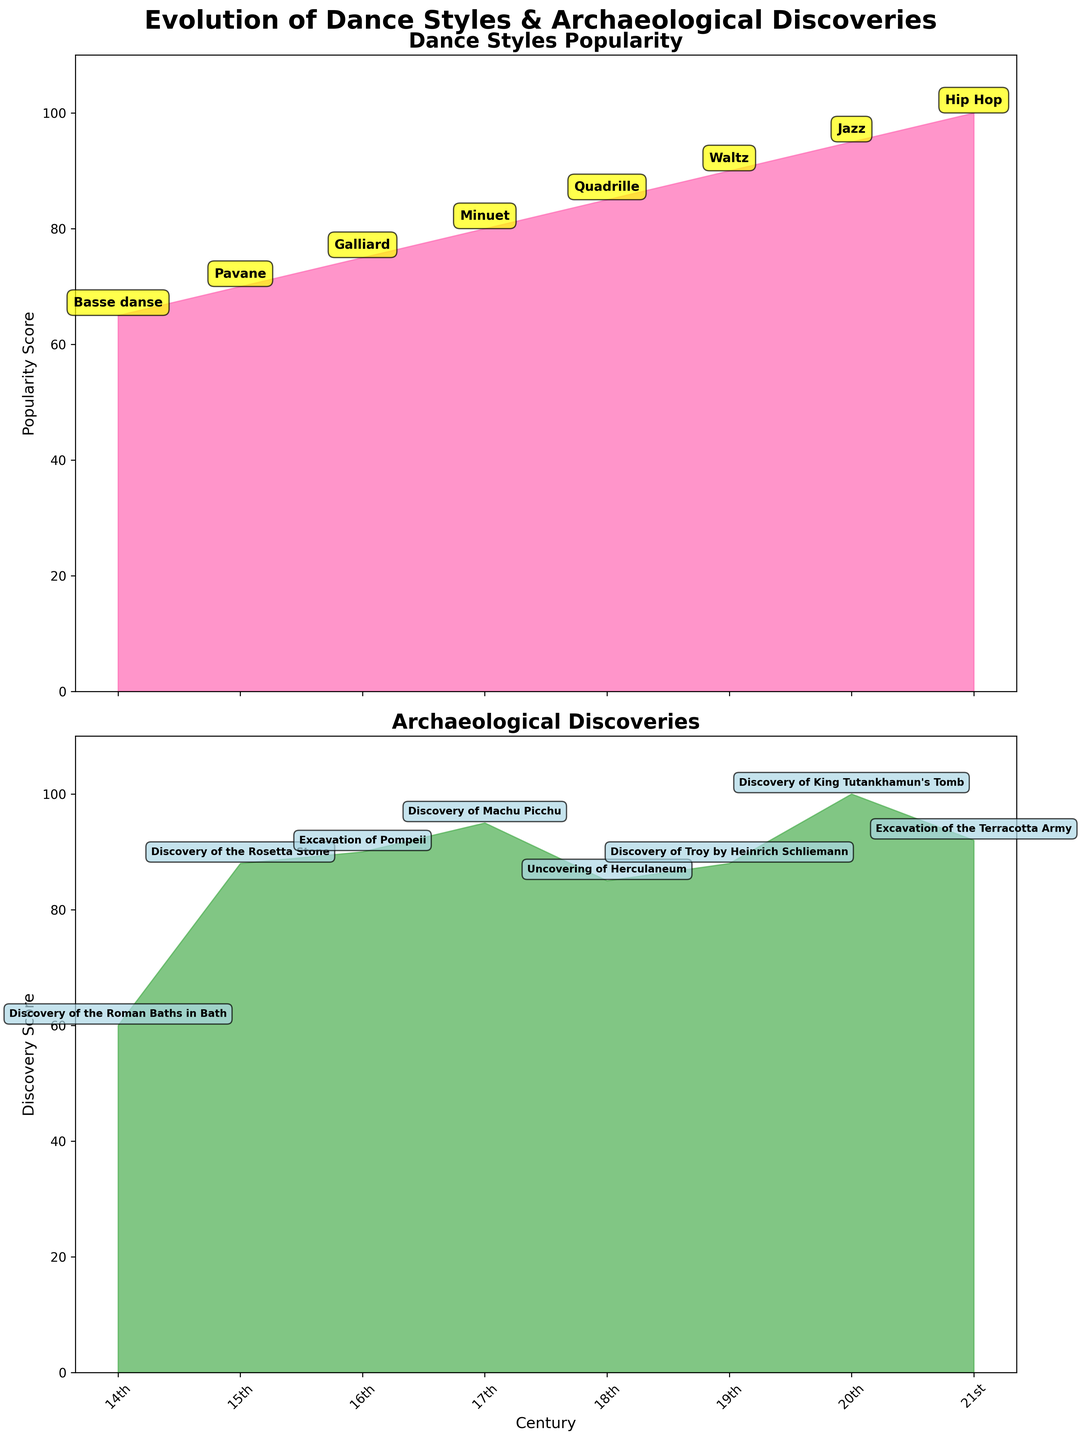What is the title of the figure? The title is located at the top center of the figure and summarizes the content. It reads "Evolution of Dance Styles & Archaeological Discoveries".
Answer: Evolution of Dance Styles & Archaeological Discoveries Which dance style has the highest popularity score? Each popularity score is listed on the subplot related to Dance Styles Popularity. The highest score is 100, associated with Hip Hop.
Answer: Hip Hop What archaeological discovery has the highest discovery score? Each discovery score is listed on the subplot related to Archaeological Discoveries. The highest score is 100, associated with the Discovery of King Tutankhamun's Tomb.
Answer: Discovery of King Tutankhamun's Tomb Between the 17th and 19th centuries, which century saw a higher rise in dance style popularity? The popularity scores for the 17th century (Minuet) and 19th century (Waltz) are 80 and 90, respectively. By comparing these values, the 19th century saw a higher rise in popularity.
Answer: 19th century What is the average discovery score between the 18th and 20th centuries? Add the discovery scores of the three centuries in question: 85 (18th), 88 (19th), and 100 (20th), then divide by 3. (85 + 88 + 100) / 3 = 91
Answer: 91 Which had a larger increase in popularity: dance styles from the 16th to 17th century or archaeological discoveries from the 19th to 20th century? Compare the increase in scores: Dance Styles (75 to 80, i.e., +5) and Archaeological Discoveries (88 to 100, i.e., +12). The larger increase is in Archaeological Discoveries.
Answer: Archaeological Discoveries from the 19th to 20th century How does the discovery score for the 18th century compare to its popularity score counterpart? The discovery score for the 18th century (Uncovering of Herculaneum) is 85, while the popularity score for the same century (Quadrille) is also 85. They are equal.
Answer: They are equal Which dance style popularity had the least increase over its previous century, and what was the increase? Examine the differences in popularity scores: Pavane (70) - Basse danse (65) = 5 (14th to 15th century), Galliard (75) - Pavane (70) = 5 (15th to 16th century). Both have the least increase of 5.
Answer: Pavane and Galliard, and the increase was 5 What is the trend in archaeological discovery scores from the 14th to the 21st century? Observe the scores: 60, 88, 90, 95, 85, 88, 100, 92. Generally, there's a noticeable increase, peaking in the 20th century at 100 before slightly decreasing in the 21st century to 92.
Answer: Generally increasing with a peak in the 20th century 